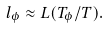<formula> <loc_0><loc_0><loc_500><loc_500>l _ { \phi } \approx L ( T _ { \phi } / T ) .</formula> 